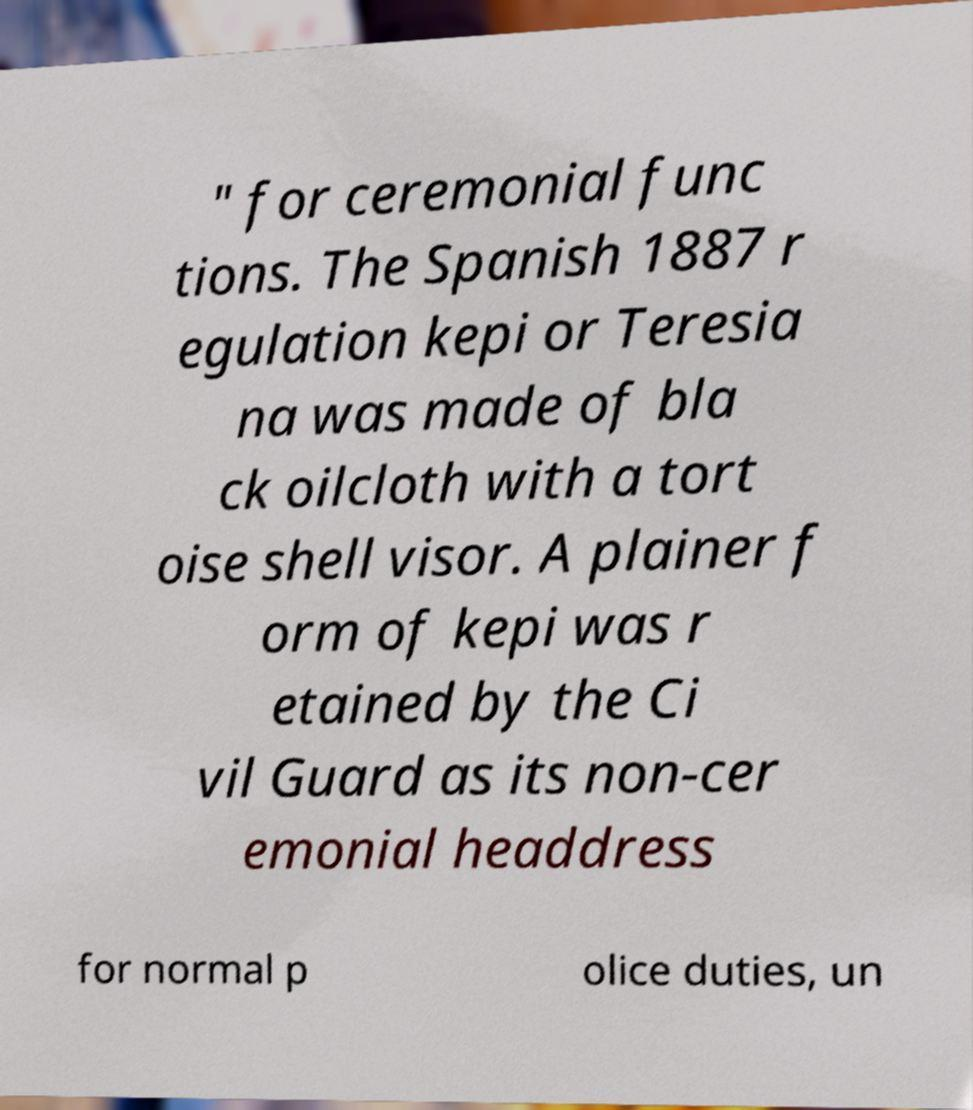Can you read and provide the text displayed in the image?This photo seems to have some interesting text. Can you extract and type it out for me? " for ceremonial func tions. The Spanish 1887 r egulation kepi or Teresia na was made of bla ck oilcloth with a tort oise shell visor. A plainer f orm of kepi was r etained by the Ci vil Guard as its non-cer emonial headdress for normal p olice duties, un 